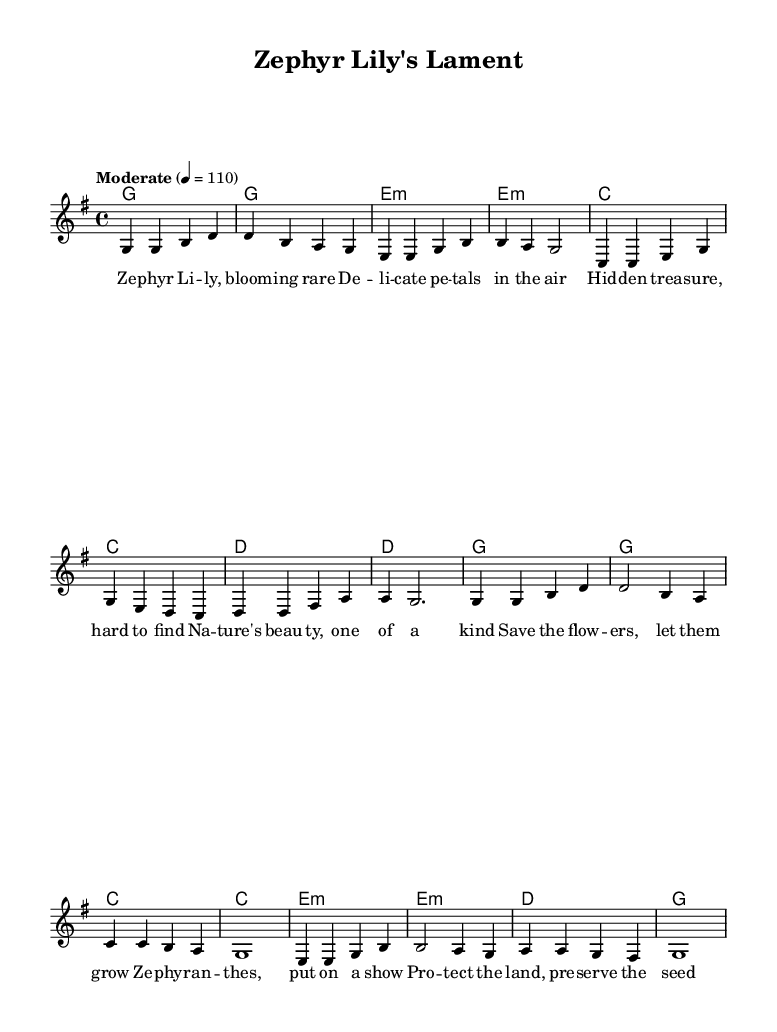What is the key signature of this music? The key signature is G major, which contains one sharp (F#). This is indicated at the beginning of the sheet music where the key signature is placed, showing that F# is the only alteration.
Answer: G major What is the time signature of this music? The time signature is 4/4, which is displayed in the early part of the sheet music. This means there are four beats in each measure and the quarter note gets one beat.
Answer: 4/4 What is the tempo marking for this piece? The tempo marking is "Moderate" with a metronome indication of 110 beats per minute, which guides the speed at which the music should be played. The term is written above the staff.
Answer: Moderate How many measures are in the verse section? The verse section contains eight measures. This is counted by noting the end of each group of notes, or bars, in the melody. Each group is separated by a line, showing the total measure count.
Answer: 8 What is the main theme of the lyrics in this song? The main theme of the lyrics is plant conservation, specifically emphasizing rare wildflowers like Zephyr lilies and the importance of preserving nature. This can be deduced from the lyrics about blooming flowers and protection of the land.
Answer: Plant conservation How do the chords change between the verse and the chorus? The chords in the verse follow a pattern of G, E minor, C, D, while the chorus shifts to G, C, E minor, and D. This change can be observed in the harmonic structure where different chords are assigned to each section, enhancing the musical contrast.
Answer: G, E minor, C, D; G, C, E minor, D What type of song structure is used in this piece? The song structure used is a verse-chorus format, typical in country rock music. This can be identified by the distinct measures devoted to verses and choruses, each having unique musical and lyrical content.
Answer: Verse-chorus 